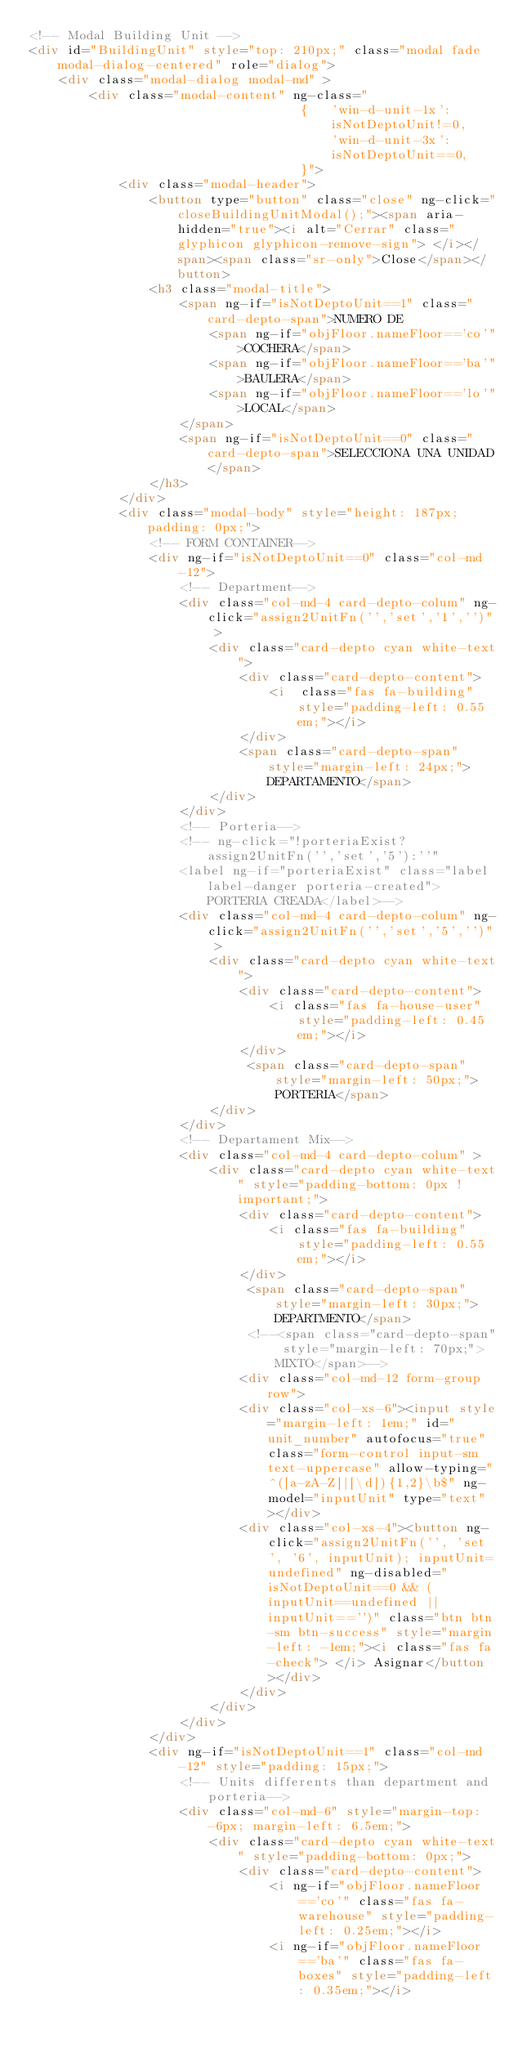Convert code to text. <code><loc_0><loc_0><loc_500><loc_500><_HTML_><!-- Modal Building Unit -->
<div id="BuildingUnit" style="top: 210px;" class="modal fade modal-dialog-centered" role="dialog">
	<div class="modal-dialog modal-md" >
	    <div class="modal-content" ng-class="
									{	'win-d-unit-1x': 
										isNotDeptoUnit!=0,
									 	'win-d-unit-3x':  
										isNotDeptoUnit==0,
									}">
	    	<div class="modal-header">
          		<button type="button" class="close" ng-click="closeBuildingUnitModal();"><span aria-hidden="true"><i alt="Cerrar" class="glyphicon glyphicon-remove-sign"> </i></span><span class="sr-only">Close</span></button>
            	<h3 class="modal-title">
		            <span ng-if="isNotDeptoUnit==1" class="card-depto-span">NUMERO DE 
		            	<span ng-if="objFloor.nameFloor=='co'">COCHERA</span>
		            	<span ng-if="objFloor.nameFloor=='ba'">BAULERA</span>
		            	<span ng-if="objFloor.nameFloor=='lo'">LOCAL</span>
		            </span>
		            <span ng-if="isNotDeptoUnit==0" class="card-depto-span">SELECCIONA UNA UNIDAD</span>
            	</h3>
        	</div>
	    	<div class="modal-body" style="height: 187px; padding: 0px;">
				<!-- FORM CONTAINER-->
				<div ng-if="isNotDeptoUnit==0" class="col-md-12"> 
					<!-- Department-->                         
				    <div class="col-md-4 card-depto-colum" ng-click="assign2UnitFn('','set','1','')" >
				        <div class="card-depto cyan white-text">
				            <div class="card-depto-content">
				                <i  class="fas fa-building" style="padding-left: 0.55em;"></i>
				            </div>
				            <span class="card-depto-span" style="margin-left: 24px;">DEPARTAMENTO</span>
				        </div>
				    </div>
				    <!-- Porteria-->
				    <!-- ng-click="!porteriaExist?assign2UnitFn('','set','5'):''" 
				    <label ng-if="porteriaExist" class="label label-danger porteria-created">PORTERIA CREADA</label>-->
				    <div class="col-md-4 card-depto-colum" ng-click="assign2UnitFn('','set','5','')" >
				        <div class="card-depto cyan white-text">
				            <div class="card-depto-content">
				            	<i class="fas fa-house-user" style="padding-left: 0.45em;"></i>
				            </div>
				             <span class="card-depto-span" style="margin-left: 50px;">PORTERIA</span>
				        </div>
				    </div>
				    <!-- Departament Mix-->
				    <div class="col-md-4 card-depto-colum" >
				        <div class="card-depto cyan white-text" style="padding-bottom: 0px !important;">
				            <div class="card-depto-content">
				            	<i class="fas fa-building" style="padding-left: 0.55em;"></i>
				            </div>
				             <span class="card-depto-span" style="margin-left: 30px;">DEPARTMENTO</span>
				             <!--<span class="card-depto-span" style="margin-left: 70px;"> MIXTO</span>-->
     				        <div class="col-md-12 form-group row">
    						<div class="col-xs-6"><input style="margin-left: 1em;" id="unit_number" autofocus="true" class="form-control input-sm text-uppercase" allow-typing="^([a-zA-Z]|[\d]){1,2}\b$" ng-model="inputUnit" type="text"></div>
							<div class="col-xs-4"><button ng-click="assign2UnitFn('', 'set', '6', inputUnit); inputUnit=undefined" ng-disabled="isNotDeptoUnit==0 && (inputUnit==undefined || inputUnit=='')" class="btn btn-sm btn-success" style="margin-left: -1em;"><i class="fas fa-check"> </i> Asignar</button></div>
							</div>
				        </div>
				    </div>				   
				</div>
				<div ng-if="isNotDeptoUnit==1" class="col-md-12" style="padding: 15px;"> 
					<!-- Units differents than department and porteria-->                         
				    <div class="col-md-6" style="margin-top: -6px; margin-left: 6.5em;">
				        <div class="card-depto cyan white-text" style="padding-bottom: 0px;">
				            <div class="card-depto-content">
				                <i ng-if="objFloor.nameFloor=='co'" class="fas fa-warehouse" style="padding-left: 0.25em;"></i>
				                <i ng-if="objFloor.nameFloor=='ba'" class="fas fa-boxes" style="padding-left: 0.35em;"></i></code> 